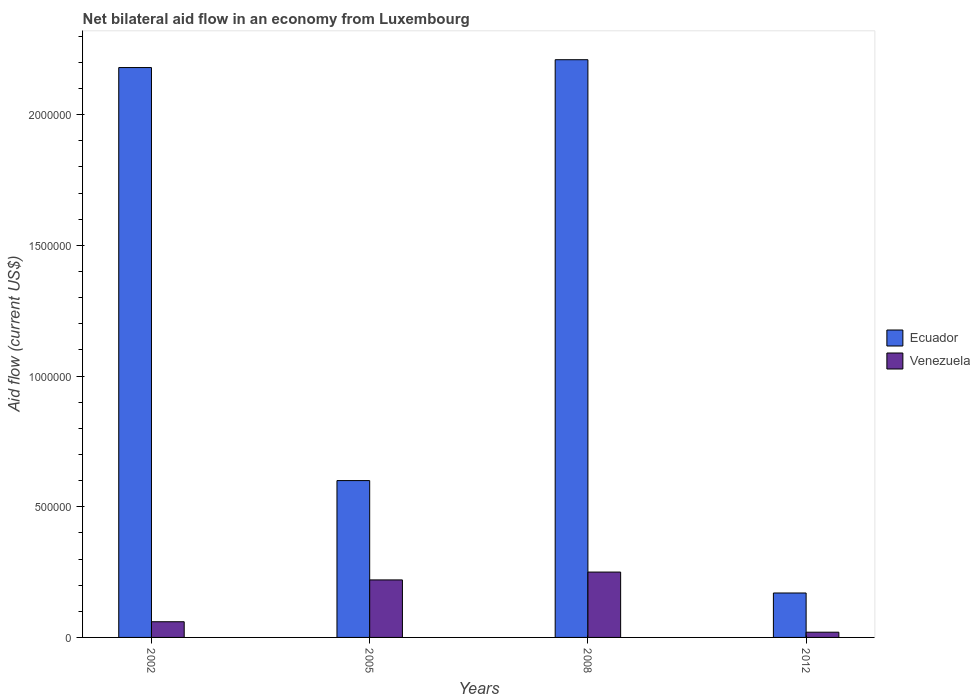How many different coloured bars are there?
Give a very brief answer. 2. How many groups of bars are there?
Your response must be concise. 4. Are the number of bars on each tick of the X-axis equal?
Make the answer very short. Yes. How many bars are there on the 1st tick from the left?
Offer a very short reply. 2. What is the net bilateral aid flow in Venezuela in 2008?
Give a very brief answer. 2.50e+05. Across all years, what is the maximum net bilateral aid flow in Ecuador?
Provide a succinct answer. 2.21e+06. Across all years, what is the minimum net bilateral aid flow in Venezuela?
Your answer should be compact. 2.00e+04. In which year was the net bilateral aid flow in Venezuela maximum?
Offer a very short reply. 2008. In which year was the net bilateral aid flow in Venezuela minimum?
Offer a very short reply. 2012. What is the total net bilateral aid flow in Ecuador in the graph?
Make the answer very short. 5.16e+06. What is the difference between the net bilateral aid flow in Venezuela in 2005 and that in 2008?
Keep it short and to the point. -3.00e+04. What is the difference between the net bilateral aid flow in Ecuador in 2008 and the net bilateral aid flow in Venezuela in 2002?
Offer a terse response. 2.15e+06. What is the average net bilateral aid flow in Venezuela per year?
Your answer should be compact. 1.38e+05. In the year 2005, what is the difference between the net bilateral aid flow in Ecuador and net bilateral aid flow in Venezuela?
Provide a short and direct response. 3.80e+05. What is the ratio of the net bilateral aid flow in Ecuador in 2002 to that in 2005?
Provide a short and direct response. 3.63. What is the difference between the highest and the second highest net bilateral aid flow in Ecuador?
Your response must be concise. 3.00e+04. What is the difference between the highest and the lowest net bilateral aid flow in Ecuador?
Your answer should be compact. 2.04e+06. In how many years, is the net bilateral aid flow in Venezuela greater than the average net bilateral aid flow in Venezuela taken over all years?
Offer a very short reply. 2. Is the sum of the net bilateral aid flow in Ecuador in 2002 and 2008 greater than the maximum net bilateral aid flow in Venezuela across all years?
Give a very brief answer. Yes. What does the 2nd bar from the left in 2002 represents?
Make the answer very short. Venezuela. What does the 1st bar from the right in 2012 represents?
Give a very brief answer. Venezuela. Are all the bars in the graph horizontal?
Ensure brevity in your answer.  No. How many years are there in the graph?
Make the answer very short. 4. How many legend labels are there?
Keep it short and to the point. 2. How are the legend labels stacked?
Keep it short and to the point. Vertical. What is the title of the graph?
Provide a succinct answer. Net bilateral aid flow in an economy from Luxembourg. What is the label or title of the X-axis?
Give a very brief answer. Years. What is the Aid flow (current US$) of Ecuador in 2002?
Make the answer very short. 2.18e+06. What is the Aid flow (current US$) of Ecuador in 2005?
Your answer should be very brief. 6.00e+05. What is the Aid flow (current US$) of Ecuador in 2008?
Offer a terse response. 2.21e+06. What is the Aid flow (current US$) of Venezuela in 2012?
Offer a terse response. 2.00e+04. Across all years, what is the maximum Aid flow (current US$) in Ecuador?
Your answer should be very brief. 2.21e+06. Across all years, what is the minimum Aid flow (current US$) in Venezuela?
Offer a terse response. 2.00e+04. What is the total Aid flow (current US$) of Ecuador in the graph?
Your answer should be very brief. 5.16e+06. What is the difference between the Aid flow (current US$) of Ecuador in 2002 and that in 2005?
Your response must be concise. 1.58e+06. What is the difference between the Aid flow (current US$) of Ecuador in 2002 and that in 2008?
Make the answer very short. -3.00e+04. What is the difference between the Aid flow (current US$) in Venezuela in 2002 and that in 2008?
Provide a short and direct response. -1.90e+05. What is the difference between the Aid flow (current US$) of Ecuador in 2002 and that in 2012?
Provide a short and direct response. 2.01e+06. What is the difference between the Aid flow (current US$) of Venezuela in 2002 and that in 2012?
Give a very brief answer. 4.00e+04. What is the difference between the Aid flow (current US$) of Ecuador in 2005 and that in 2008?
Keep it short and to the point. -1.61e+06. What is the difference between the Aid flow (current US$) in Ecuador in 2005 and that in 2012?
Keep it short and to the point. 4.30e+05. What is the difference between the Aid flow (current US$) in Ecuador in 2008 and that in 2012?
Ensure brevity in your answer.  2.04e+06. What is the difference between the Aid flow (current US$) of Ecuador in 2002 and the Aid flow (current US$) of Venezuela in 2005?
Offer a very short reply. 1.96e+06. What is the difference between the Aid flow (current US$) of Ecuador in 2002 and the Aid flow (current US$) of Venezuela in 2008?
Offer a terse response. 1.93e+06. What is the difference between the Aid flow (current US$) of Ecuador in 2002 and the Aid flow (current US$) of Venezuela in 2012?
Provide a short and direct response. 2.16e+06. What is the difference between the Aid flow (current US$) of Ecuador in 2005 and the Aid flow (current US$) of Venezuela in 2008?
Keep it short and to the point. 3.50e+05. What is the difference between the Aid flow (current US$) of Ecuador in 2005 and the Aid flow (current US$) of Venezuela in 2012?
Offer a very short reply. 5.80e+05. What is the difference between the Aid flow (current US$) of Ecuador in 2008 and the Aid flow (current US$) of Venezuela in 2012?
Your answer should be very brief. 2.19e+06. What is the average Aid flow (current US$) in Ecuador per year?
Provide a succinct answer. 1.29e+06. What is the average Aid flow (current US$) of Venezuela per year?
Ensure brevity in your answer.  1.38e+05. In the year 2002, what is the difference between the Aid flow (current US$) of Ecuador and Aid flow (current US$) of Venezuela?
Give a very brief answer. 2.12e+06. In the year 2005, what is the difference between the Aid flow (current US$) in Ecuador and Aid flow (current US$) in Venezuela?
Provide a short and direct response. 3.80e+05. In the year 2008, what is the difference between the Aid flow (current US$) in Ecuador and Aid flow (current US$) in Venezuela?
Provide a short and direct response. 1.96e+06. What is the ratio of the Aid flow (current US$) in Ecuador in 2002 to that in 2005?
Make the answer very short. 3.63. What is the ratio of the Aid flow (current US$) of Venezuela in 2002 to that in 2005?
Offer a very short reply. 0.27. What is the ratio of the Aid flow (current US$) of Ecuador in 2002 to that in 2008?
Make the answer very short. 0.99. What is the ratio of the Aid flow (current US$) of Venezuela in 2002 to that in 2008?
Keep it short and to the point. 0.24. What is the ratio of the Aid flow (current US$) in Ecuador in 2002 to that in 2012?
Ensure brevity in your answer.  12.82. What is the ratio of the Aid flow (current US$) in Venezuela in 2002 to that in 2012?
Offer a terse response. 3. What is the ratio of the Aid flow (current US$) of Ecuador in 2005 to that in 2008?
Offer a very short reply. 0.27. What is the ratio of the Aid flow (current US$) of Venezuela in 2005 to that in 2008?
Offer a very short reply. 0.88. What is the ratio of the Aid flow (current US$) of Ecuador in 2005 to that in 2012?
Offer a very short reply. 3.53. What is the ratio of the Aid flow (current US$) of Ecuador in 2008 to that in 2012?
Give a very brief answer. 13. What is the difference between the highest and the lowest Aid flow (current US$) of Ecuador?
Offer a very short reply. 2.04e+06. What is the difference between the highest and the lowest Aid flow (current US$) in Venezuela?
Provide a short and direct response. 2.30e+05. 